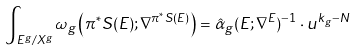Convert formula to latex. <formula><loc_0><loc_0><loc_500><loc_500>\int _ { E ^ { g } / X ^ { g } } \omega _ { g } \left ( \pi ^ { * } S ( E ) ; \nabla ^ { \pi ^ { * } S ( E ) } \right ) = \hat { \alpha } _ { g } ( E ; \nabla ^ { E } ) ^ { - 1 } \cdot u ^ { k _ { g } - N }</formula> 